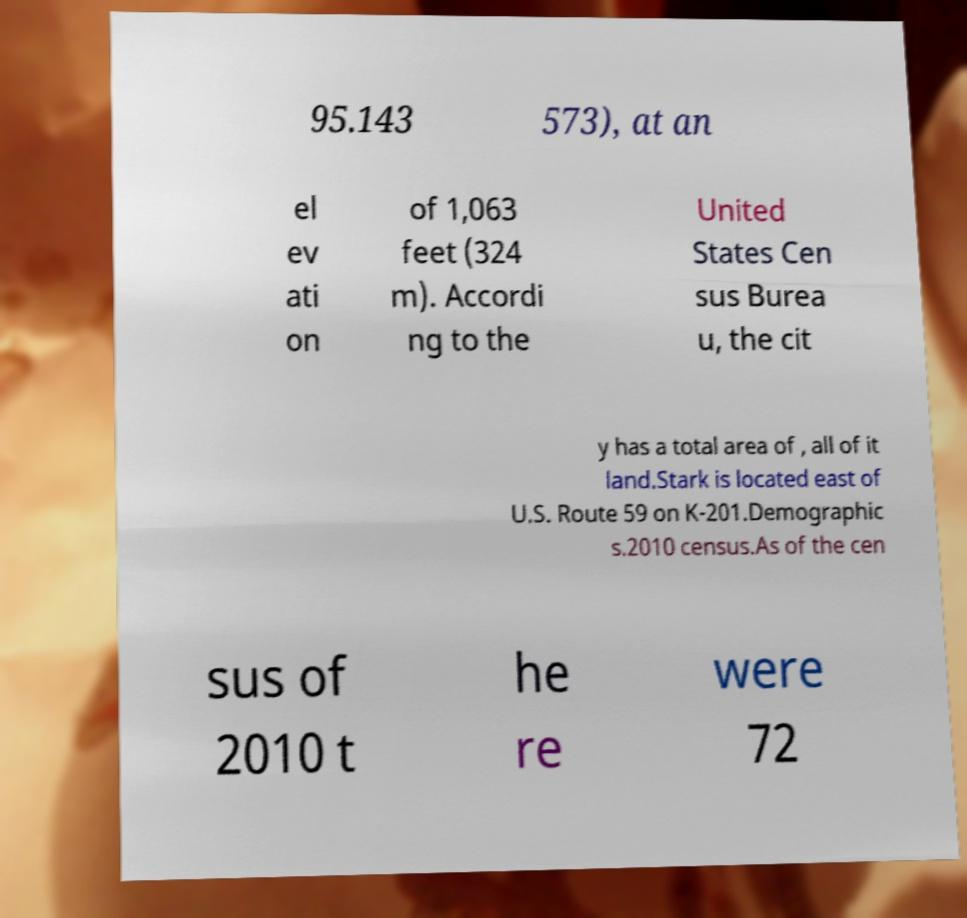Please identify and transcribe the text found in this image. 95.143 573), at an el ev ati on of 1,063 feet (324 m). Accordi ng to the United States Cen sus Burea u, the cit y has a total area of , all of it land.Stark is located east of U.S. Route 59 on K-201.Demographic s.2010 census.As of the cen sus of 2010 t he re were 72 